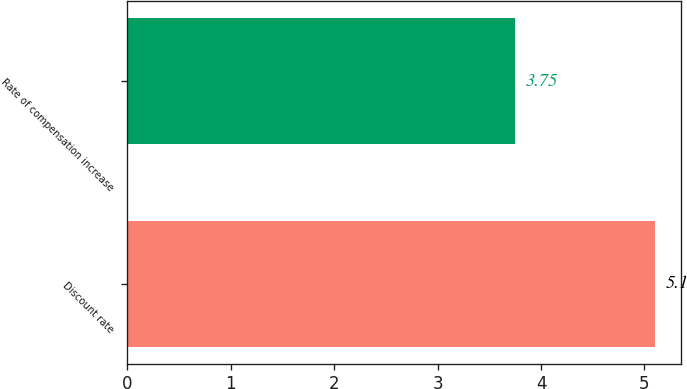Convert chart to OTSL. <chart><loc_0><loc_0><loc_500><loc_500><bar_chart><fcel>Discount rate<fcel>Rate of compensation increase<nl><fcel>5.1<fcel>3.75<nl></chart> 